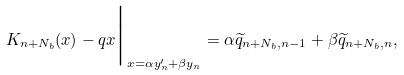<formula> <loc_0><loc_0><loc_500><loc_500>K _ { n + N _ { b } } ( x ) - q x \Big | _ { x = \alpha y _ { n } ^ { \prime } + \beta y _ { n } } = \alpha \widetilde { q } _ { n + N _ { b } , n - 1 } + \beta \widetilde { q } _ { n + N _ { b } , n } ,</formula> 